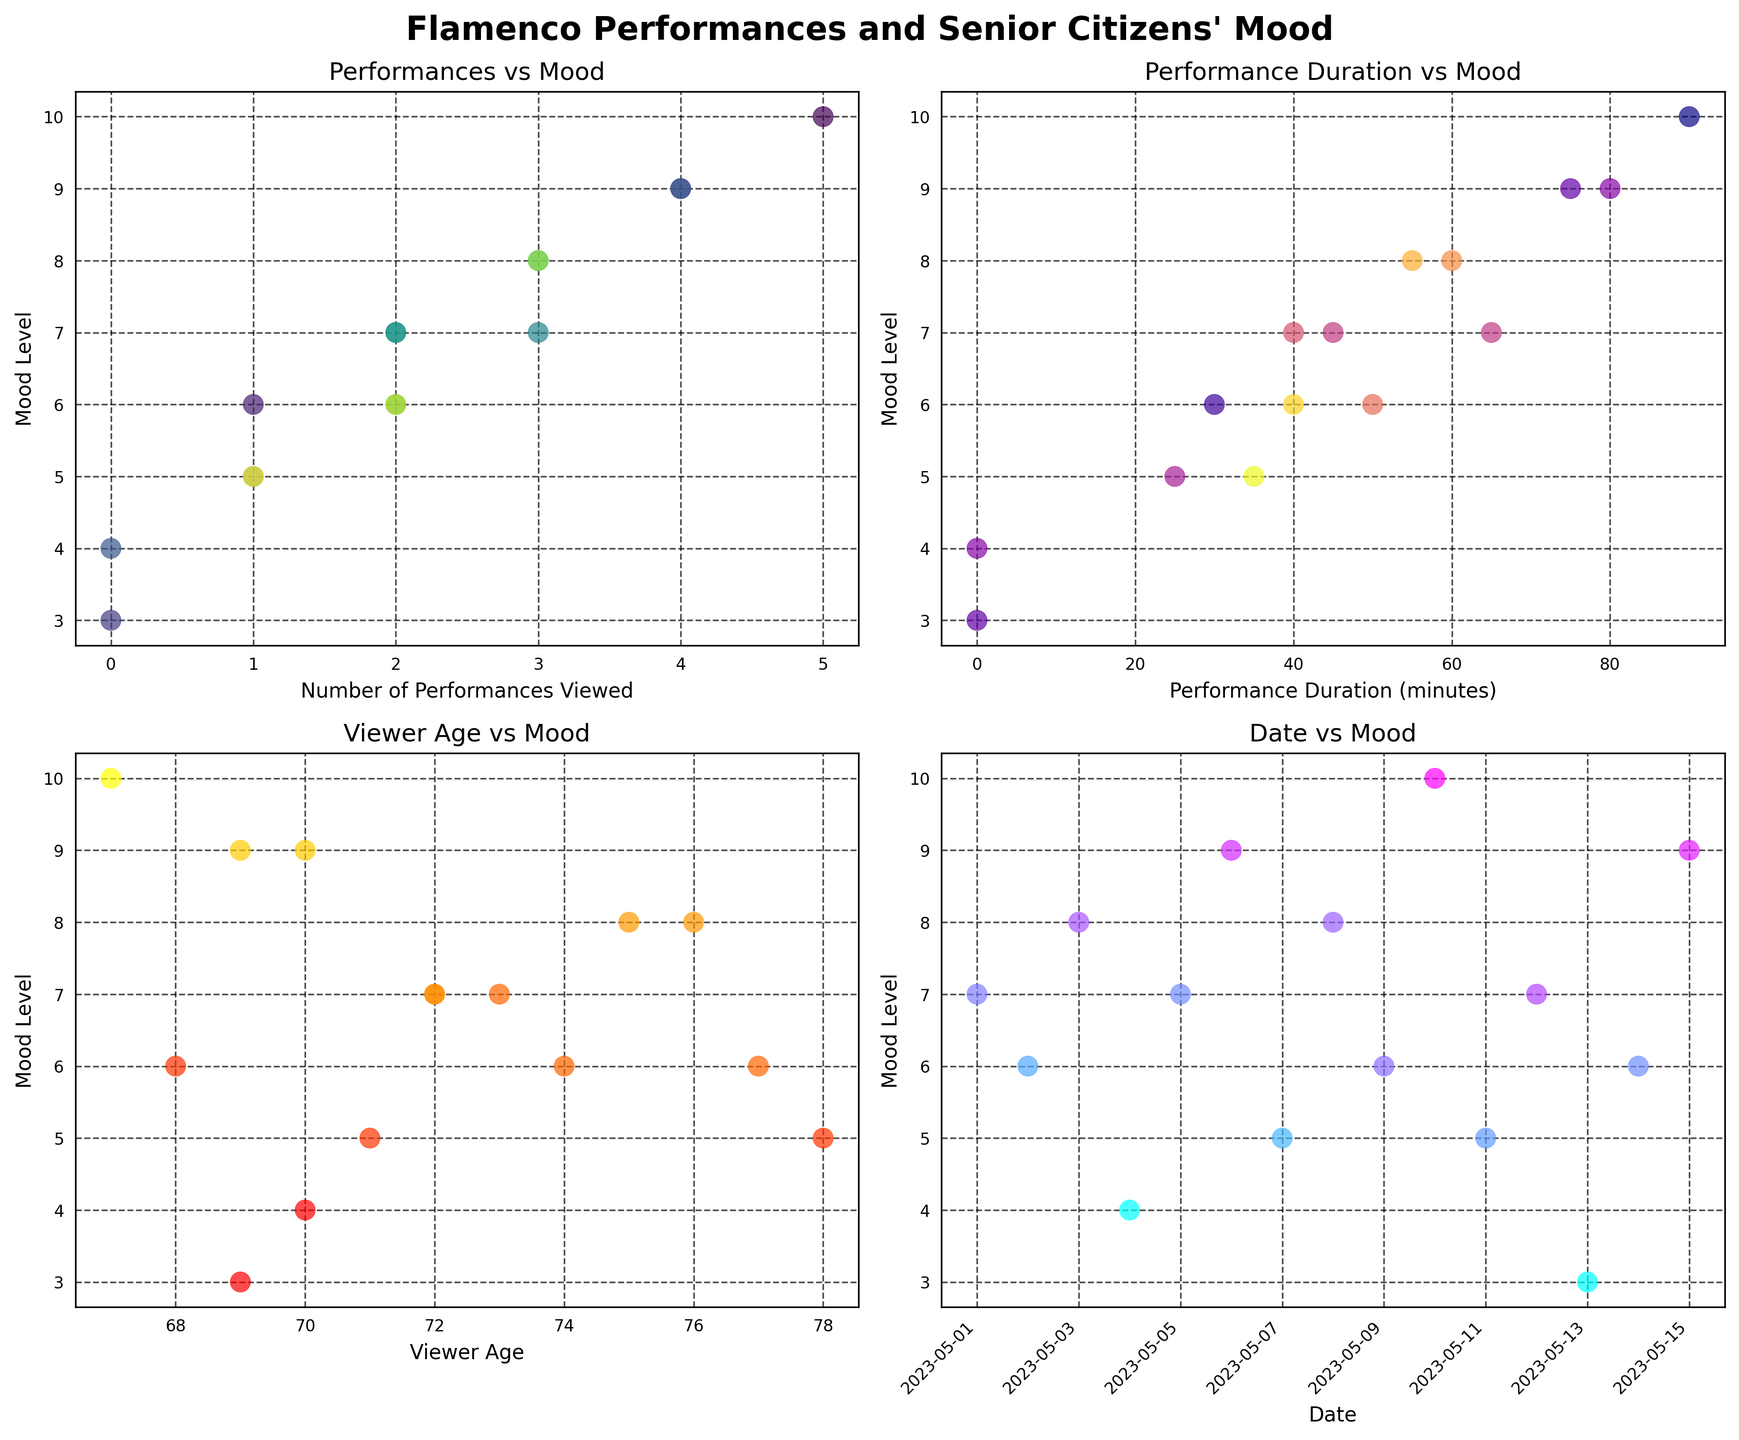what is the title of the subplot located at the top left corner? The title is written above the scatter plot in the top left corner, labeled "Performances vs Mood".
Answer: Performances vs Mood how many performances were viewed on 2023-05-10? In the bottom right plot, the x-axis shows dates, and by looking at the scatter point for 2023-05-10, it reflects 5 performances viewed.
Answer: 5 which subplot shows the relationship between performance duration and mood level? By reading the titles above each subplot, the one titled 'Performance Duration vs Mood' indicates the relationship between performance duration and mood level and is located in the top right corner.
Answer: Performance Duration vs Mood what is the mood level when the performance duration is 80 minutes? By looking at the Performance Duration vs Mood subplot in the top right corner, the point aligned with the 80-minute mark on the x-axis hits the y-axis at mood level 9.
Answer: 9 does the viewer's age influence mood level based on the plots? In the Viewer Age vs Mood subplot, observe whether a specific age range consistently appears with high or low mood levels. There is typically variability, suggesting no direct age influence.
Answer: No direct influence on what date did senior citizens report the lowest mood level? In the Date vs Mood subplot, the lowest point on the y-axis indicates the lowest mood level and its corresponding date is 2023-05-13.
Answer: 2023-05-13 is there a trend that more performances viewed correlate with higher mood levels? Observing the Performances vs Mood subplot, points generally trend upward, indicating higher mood levels with more performances viewed.
Answer: Yes how does performance duration affect mood level irrespective of the performance count? In the Performance Duration vs Mood plot, more extended performance durations also show higher mood levels, though not strictly linear.
Answer: Positive correlation are mood levels generally higher for younger or older viewers? Reviewing the Viewer Age vs Mood plot, there are no glaring trends, with high mood levels spread across different ages.
Answer: No clear trend what is the color representing the oldest viewer in the subplot performance duration vs mood? In the Performance Duration vs Mood plot, the color gradient (plasma) indicates older viewers with darker colors. The oldest viewer is indicated by a darker blue.
Answer: Dark Blue 